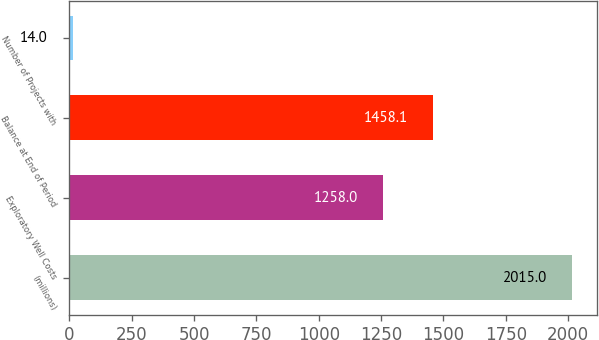Convert chart. <chart><loc_0><loc_0><loc_500><loc_500><bar_chart><fcel>(millions)<fcel>Exploratory Well Costs<fcel>Balance at End of Period<fcel>Number of Projects with<nl><fcel>2015<fcel>1258<fcel>1458.1<fcel>14<nl></chart> 